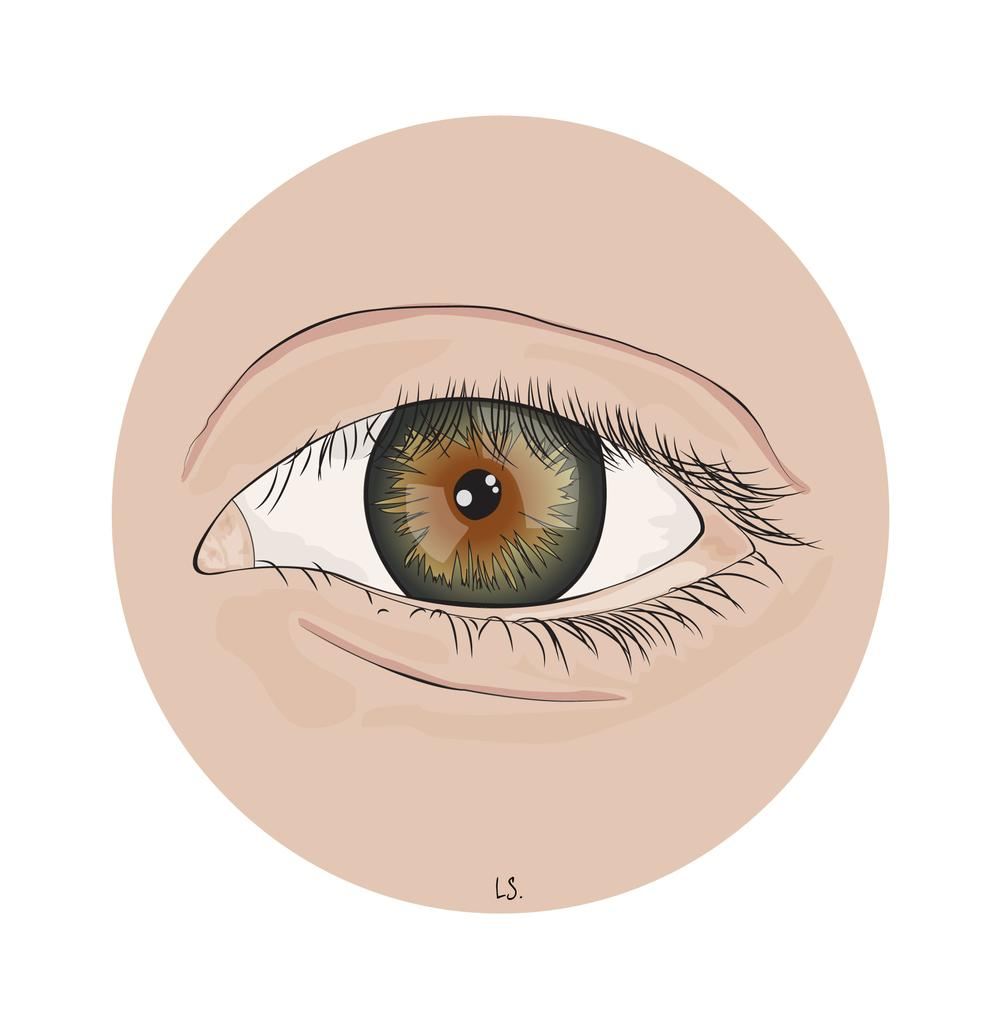What type of art is featured in the image? The image contains digital art. What is the subject of the digital art? The digital art is of a person's eye. How many colors can be seen in the eye? The eye has cream, white, black, and brown colors. What color is the background of the image? The background of the image is white. What direction is the turkey facing in the image? There is no turkey present in the image; it features digital art of a person's eye. 